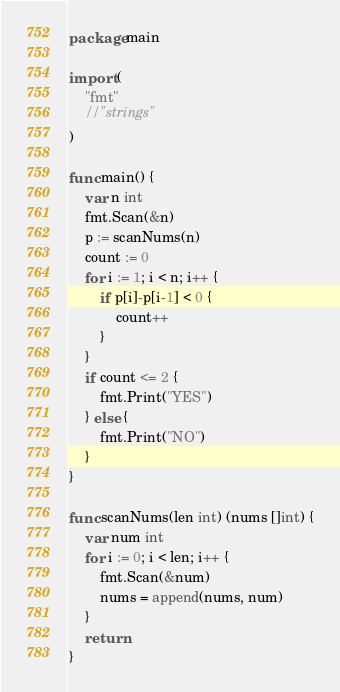<code> <loc_0><loc_0><loc_500><loc_500><_Go_>package main

import (
	"fmt"
	//"strings"
)

func main() {
	var n int
	fmt.Scan(&n)
	p := scanNums(n)
	count := 0
	for i := 1; i < n; i++ {
		if p[i]-p[i-1] < 0 {
			count++
		}
	}
	if count <= 2 {
		fmt.Print("YES")
	} else {
		fmt.Print("NO")
	}
}

func scanNums(len int) (nums []int) {
	var num int
	for i := 0; i < len; i++ {
		fmt.Scan(&num)
		nums = append(nums, num)
	}
	return
}</code> 